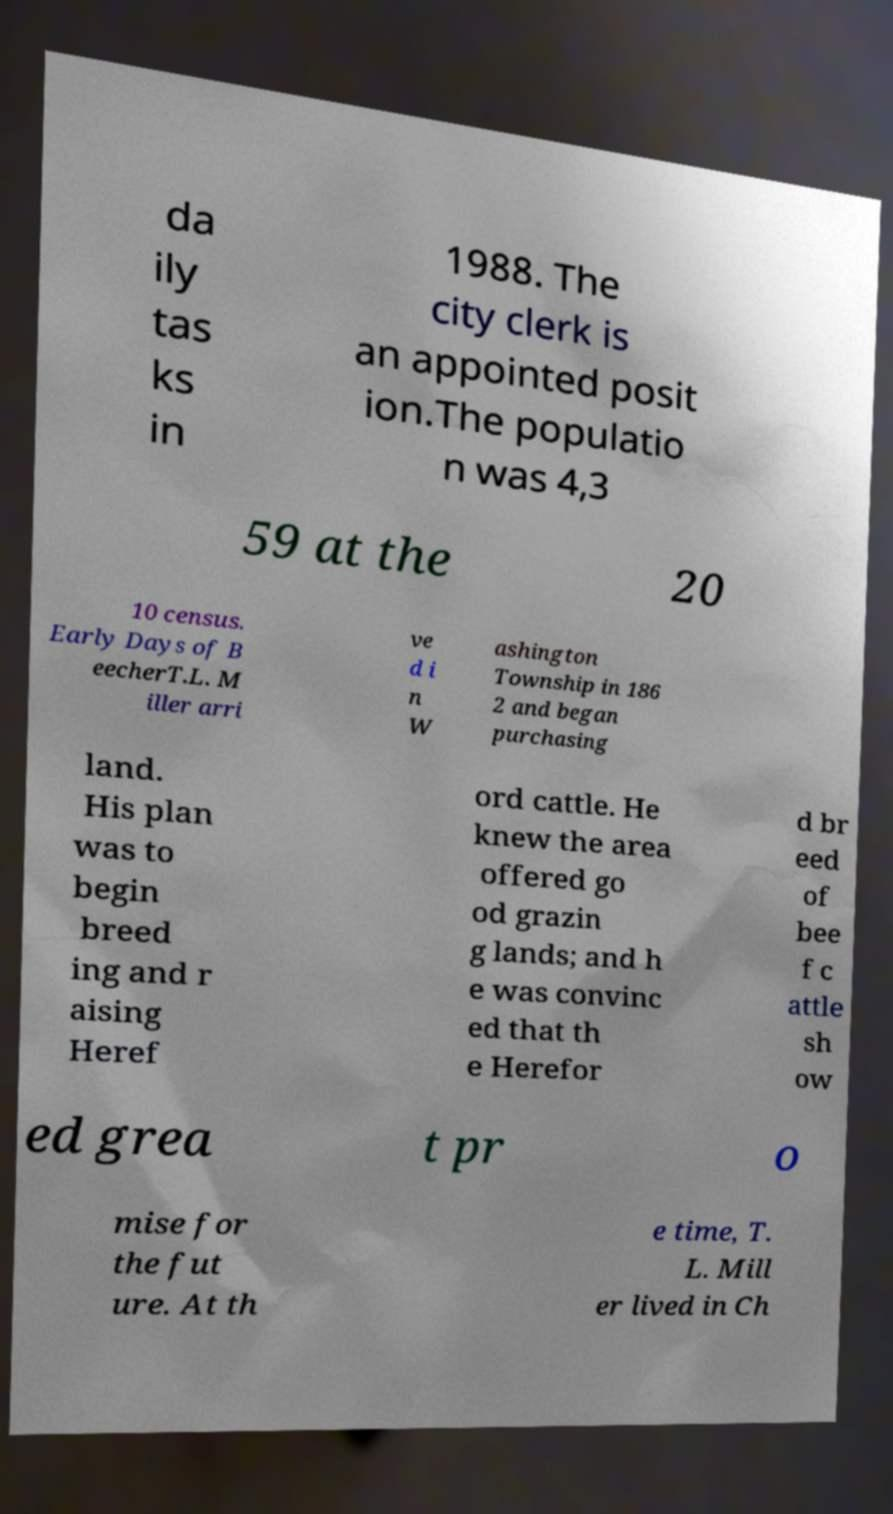Can you accurately transcribe the text from the provided image for me? da ily tas ks in 1988. The city clerk is an appointed posit ion.The populatio n was 4,3 59 at the 20 10 census. Early Days of B eecherT.L. M iller arri ve d i n W ashington Township in 186 2 and began purchasing land. His plan was to begin breed ing and r aising Heref ord cattle. He knew the area offered go od grazin g lands; and h e was convinc ed that th e Herefor d br eed of bee f c attle sh ow ed grea t pr o mise for the fut ure. At th e time, T. L. Mill er lived in Ch 